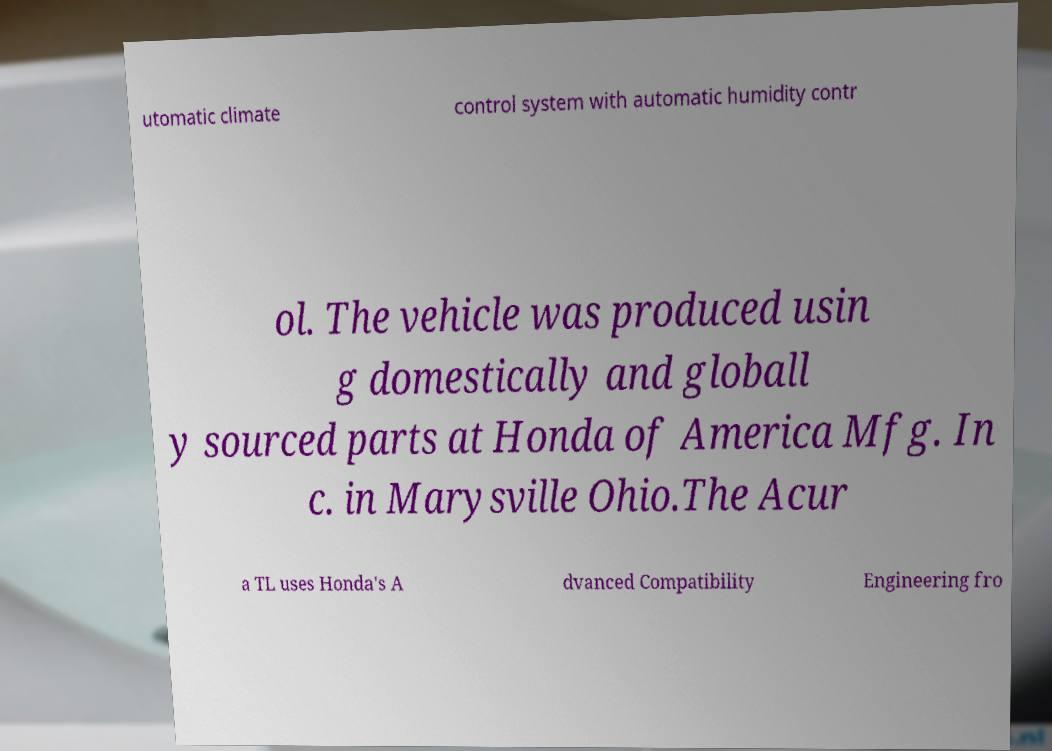Could you assist in decoding the text presented in this image and type it out clearly? utomatic climate control system with automatic humidity contr ol. The vehicle was produced usin g domestically and globall y sourced parts at Honda of America Mfg. In c. in Marysville Ohio.The Acur a TL uses Honda's A dvanced Compatibility Engineering fro 